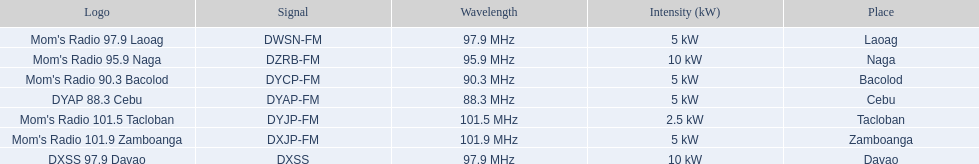What is the power capacity in kw for each team? 5 kW, 10 kW, 5 kW, 5 kW, 2.5 kW, 5 kW, 10 kW. Which is the lowest? 2.5 kW. What station has this amount of power? Mom's Radio 101.5 Tacloban. 